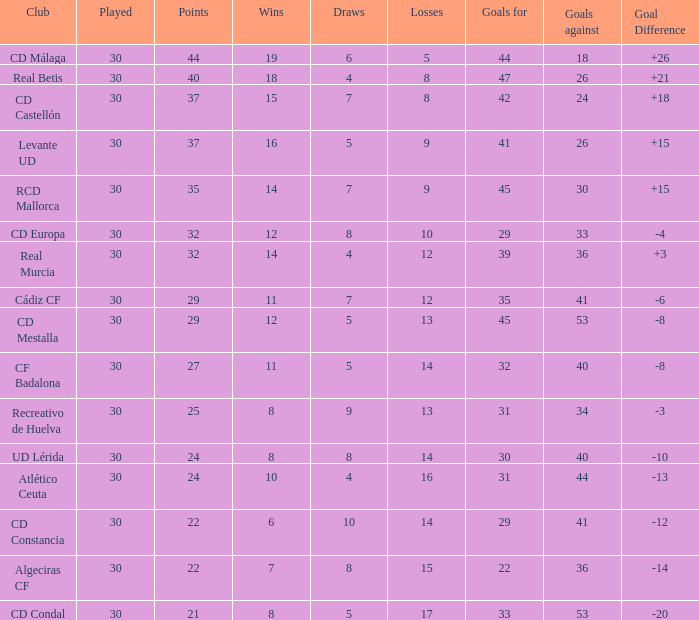What is the goals for when played is larger than 30? None. Parse the table in full. {'header': ['Club', 'Played', 'Points', 'Wins', 'Draws', 'Losses', 'Goals for', 'Goals against', 'Goal Difference'], 'rows': [['CD Málaga', '30', '44', '19', '6', '5', '44', '18', '+26'], ['Real Betis', '30', '40', '18', '4', '8', '47', '26', '+21'], ['CD Castellón', '30', '37', '15', '7', '8', '42', '24', '+18'], ['Levante UD', '30', '37', '16', '5', '9', '41', '26', '+15'], ['RCD Mallorca', '30', '35', '14', '7', '9', '45', '30', '+15'], ['CD Europa', '30', '32', '12', '8', '10', '29', '33', '-4'], ['Real Murcia', '30', '32', '14', '4', '12', '39', '36', '+3'], ['Cádiz CF', '30', '29', '11', '7', '12', '35', '41', '-6'], ['CD Mestalla', '30', '29', '12', '5', '13', '45', '53', '-8'], ['CF Badalona', '30', '27', '11', '5', '14', '32', '40', '-8'], ['Recreativo de Huelva', '30', '25', '8', '9', '13', '31', '34', '-3'], ['UD Lérida', '30', '24', '8', '8', '14', '30', '40', '-10'], ['Atlético Ceuta', '30', '24', '10', '4', '16', '31', '44', '-13'], ['CD Constancia', '30', '22', '6', '10', '14', '29', '41', '-12'], ['Algeciras CF', '30', '22', '7', '8', '15', '22', '36', '-14'], ['CD Condal', '30', '21', '8', '5', '17', '33', '53', '-20']]} 